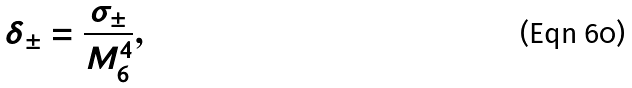<formula> <loc_0><loc_0><loc_500><loc_500>\delta _ { \pm } = \frac { \sigma _ { \pm } } { M _ { 6 } ^ { 4 } } ,</formula> 